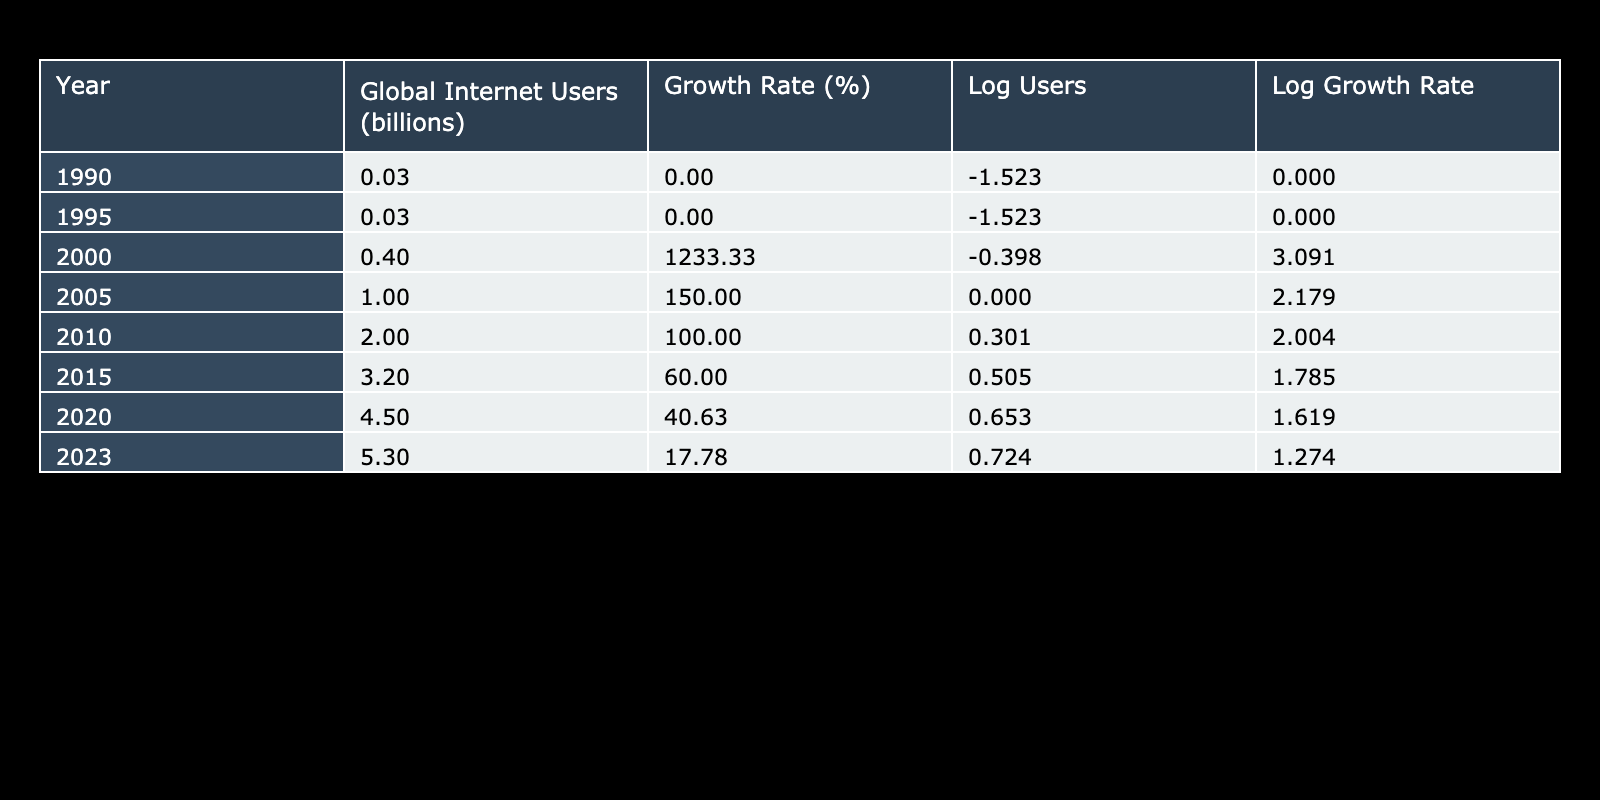What was the Global Internet Users in 2005? In the table, under the column "Global Internet Users (in billions)" for the year 2005, the value is given as 1.0 billion.
Answer: 1.0 billion What is the Growth Rate in 2010? Looking at the "Growth Rate (%)" column for the year 2010, the value is clearly stated as 100%.
Answer: 100% Which year saw the highest Growth Rate? By checking the "Growth Rate (%)" column, the year with the highest growth rate is 2000, showing a growth of 1233.33%.
Answer: 2000 Is the Growth Rate higher in 2020 than in 2015? Comparing the values, the Growth Rate in 2020 is 40.63%, while in 2015 it was 60%. Since 40.63% is less than 60%, the answer is no.
Answer: No What is the total increase in Global Internet Users from 1990 to 2023? The Global Internet Users in 1990 is 0.03 billion and in 2023 is 5.3 billion. The increase is calculated by subtracting 0.03 from 5.3, which gives 5.27 billion.
Answer: 5.27 billion What is the average Growth Rate from 2000 to 2023? The Growth Rates for these years are 1233.33% (2000), 150.00% (2005), 100.00% (2010), 60.00% (2015), 40.63% (2020), and 17.78% (2023). Adding these gives 1601.74%, and dividing by 6 gives an average of approximately 266.96%.
Answer: 266.96% Was there any year when no growth occurred? Referring to the Growth Rate (%) column, the years 1990 and 1995 both show a growth rate of 0%, indicating no growth. Hence, the answer is yes.
Answer: Yes In what year did the number of Global Internet Users double for the first time? The number of Global Internet Users increased from 0.4 billion in 2000 to 1.0 billion in 2005, which is doubling. Thus, the year it first doubled is 2005.
Answer: 2005 What is the difference in Log Growth Rate between 2010 and 2020? The Log Growth Rate for 2010 is calculated as log10(100 + 1) which is approximately 2, and for 2020 it is log10(40.63 + 1), which is approximately 1.61. The difference is 2 - 1.61 = 0.39.
Answer: 0.39 